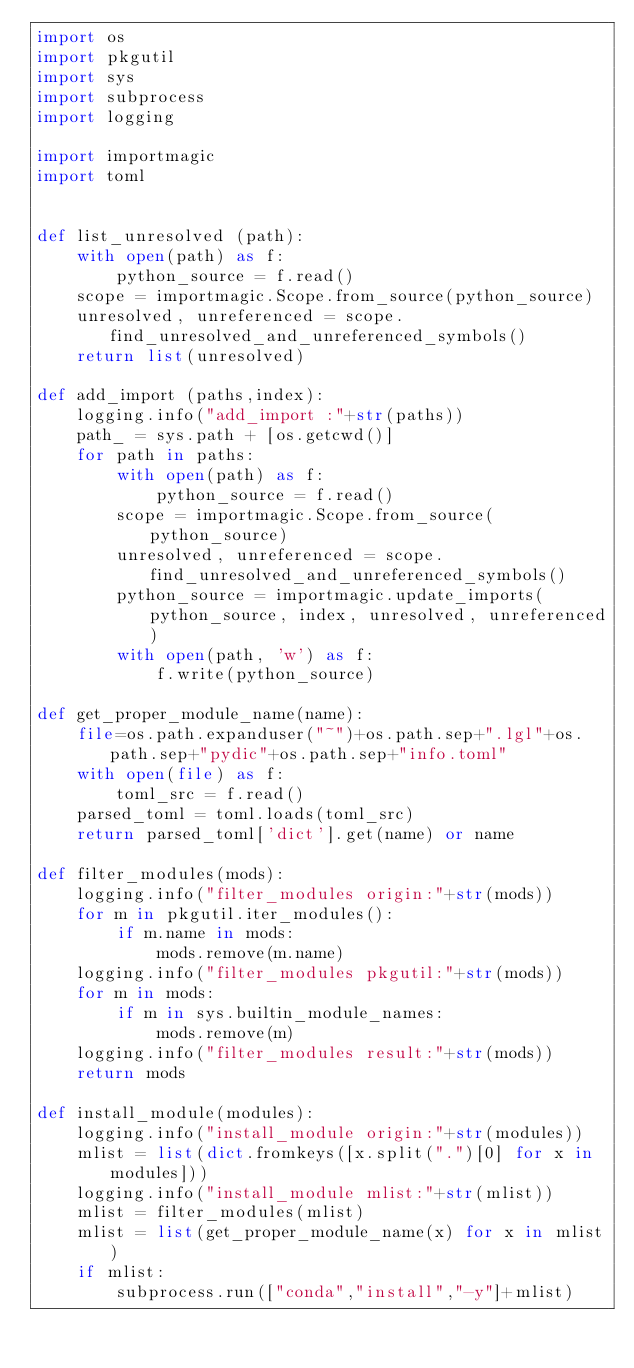Convert code to text. <code><loc_0><loc_0><loc_500><loc_500><_Python_>import os
import pkgutil
import sys
import subprocess
import logging

import importmagic
import toml


def list_unresolved (path):
    with open(path) as f:
        python_source = f.read()
    scope = importmagic.Scope.from_source(python_source)
    unresolved, unreferenced = scope.find_unresolved_and_unreferenced_symbols()
    return list(unresolved)

def add_import (paths,index):
    logging.info("add_import :"+str(paths))
    path_ = sys.path + [os.getcwd()]
    for path in paths:
        with open(path) as f:
            python_source = f.read()
        scope = importmagic.Scope.from_source(python_source)
        unresolved, unreferenced = scope.find_unresolved_and_unreferenced_symbols()
        python_source = importmagic.update_imports(python_source, index, unresolved, unreferenced)
        with open(path, 'w') as f:
            f.write(python_source)

def get_proper_module_name(name):
    file=os.path.expanduser("~")+os.path.sep+".lgl"+os.path.sep+"pydic"+os.path.sep+"info.toml"
    with open(file) as f:
        toml_src = f.read()
    parsed_toml = toml.loads(toml_src)
    return parsed_toml['dict'].get(name) or name

def filter_modules(mods):
    logging.info("filter_modules origin:"+str(mods))
    for m in pkgutil.iter_modules():
        if m.name in mods:
            mods.remove(m.name)
    logging.info("filter_modules pkgutil:"+str(mods))
    for m in mods:
        if m in sys.builtin_module_names:
            mods.remove(m)
    logging.info("filter_modules result:"+str(mods))
    return mods

def install_module(modules):
    logging.info("install_module origin:"+str(modules))
    mlist = list(dict.fromkeys([x.split(".")[0] for x in modules]))
    logging.info("install_module mlist:"+str(mlist))
    mlist = filter_modules(mlist)
    mlist = list(get_proper_module_name(x) for x in mlist)
    if mlist:
        subprocess.run(["conda","install","-y"]+mlist)
</code> 